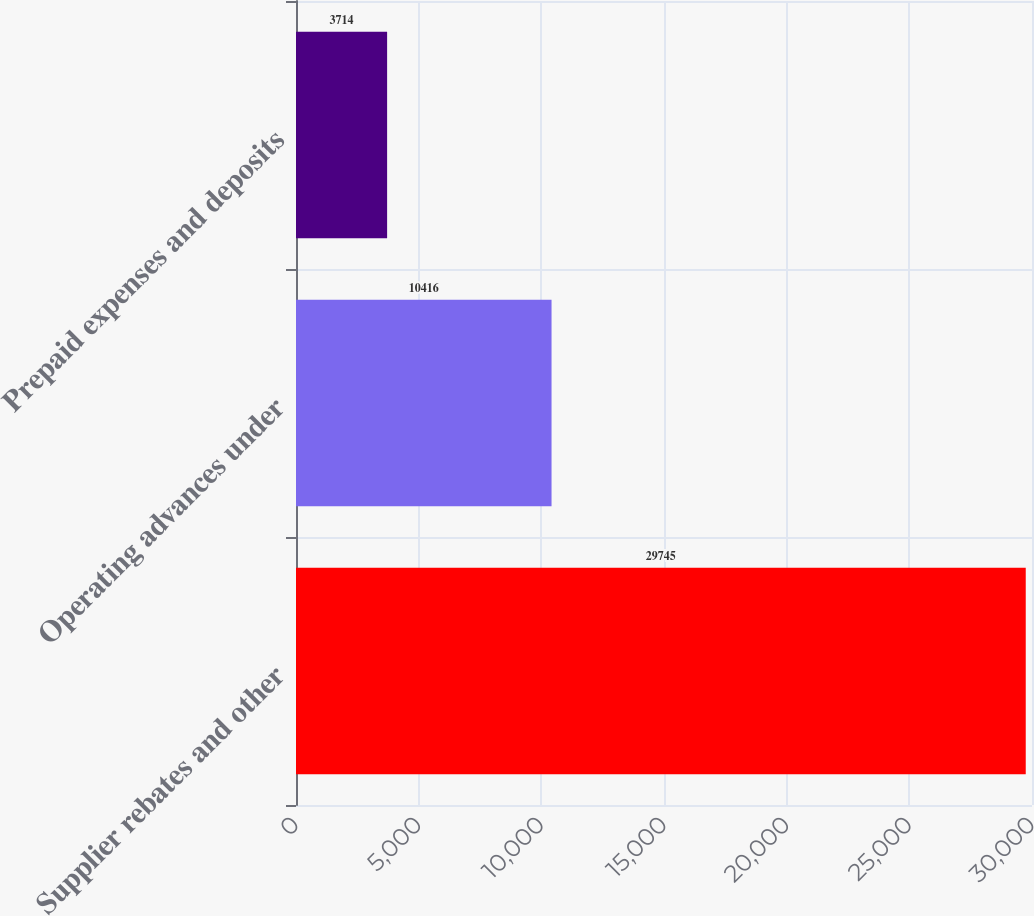Convert chart. <chart><loc_0><loc_0><loc_500><loc_500><bar_chart><fcel>Supplier rebates and other<fcel>Operating advances under<fcel>Prepaid expenses and deposits<nl><fcel>29745<fcel>10416<fcel>3714<nl></chart> 